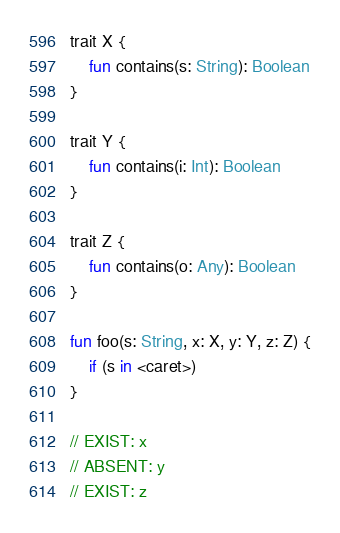<code> <loc_0><loc_0><loc_500><loc_500><_Kotlin_>trait X {
    fun contains(s: String): Boolean
}

trait Y {
    fun contains(i: Int): Boolean
}

trait Z {
    fun contains(o: Any): Boolean
}

fun foo(s: String, x: X, y: Y, z: Z) {
    if (s in <caret>)
}

// EXIST: x
// ABSENT: y
// EXIST: z
</code> 